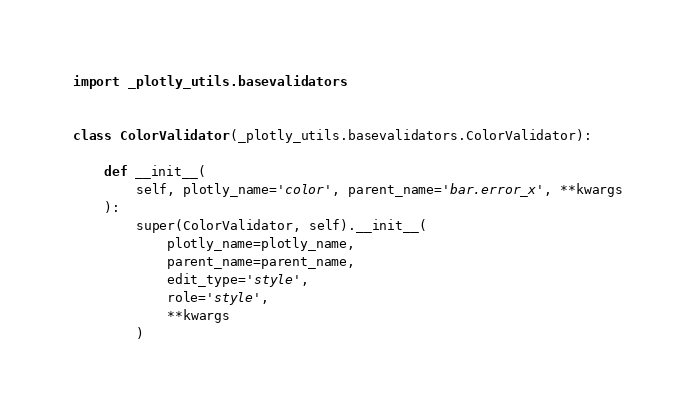<code> <loc_0><loc_0><loc_500><loc_500><_Python_>import _plotly_utils.basevalidators


class ColorValidator(_plotly_utils.basevalidators.ColorValidator):

    def __init__(
        self, plotly_name='color', parent_name='bar.error_x', **kwargs
    ):
        super(ColorValidator, self).__init__(
            plotly_name=plotly_name,
            parent_name=parent_name,
            edit_type='style',
            role='style',
            **kwargs
        )
</code> 